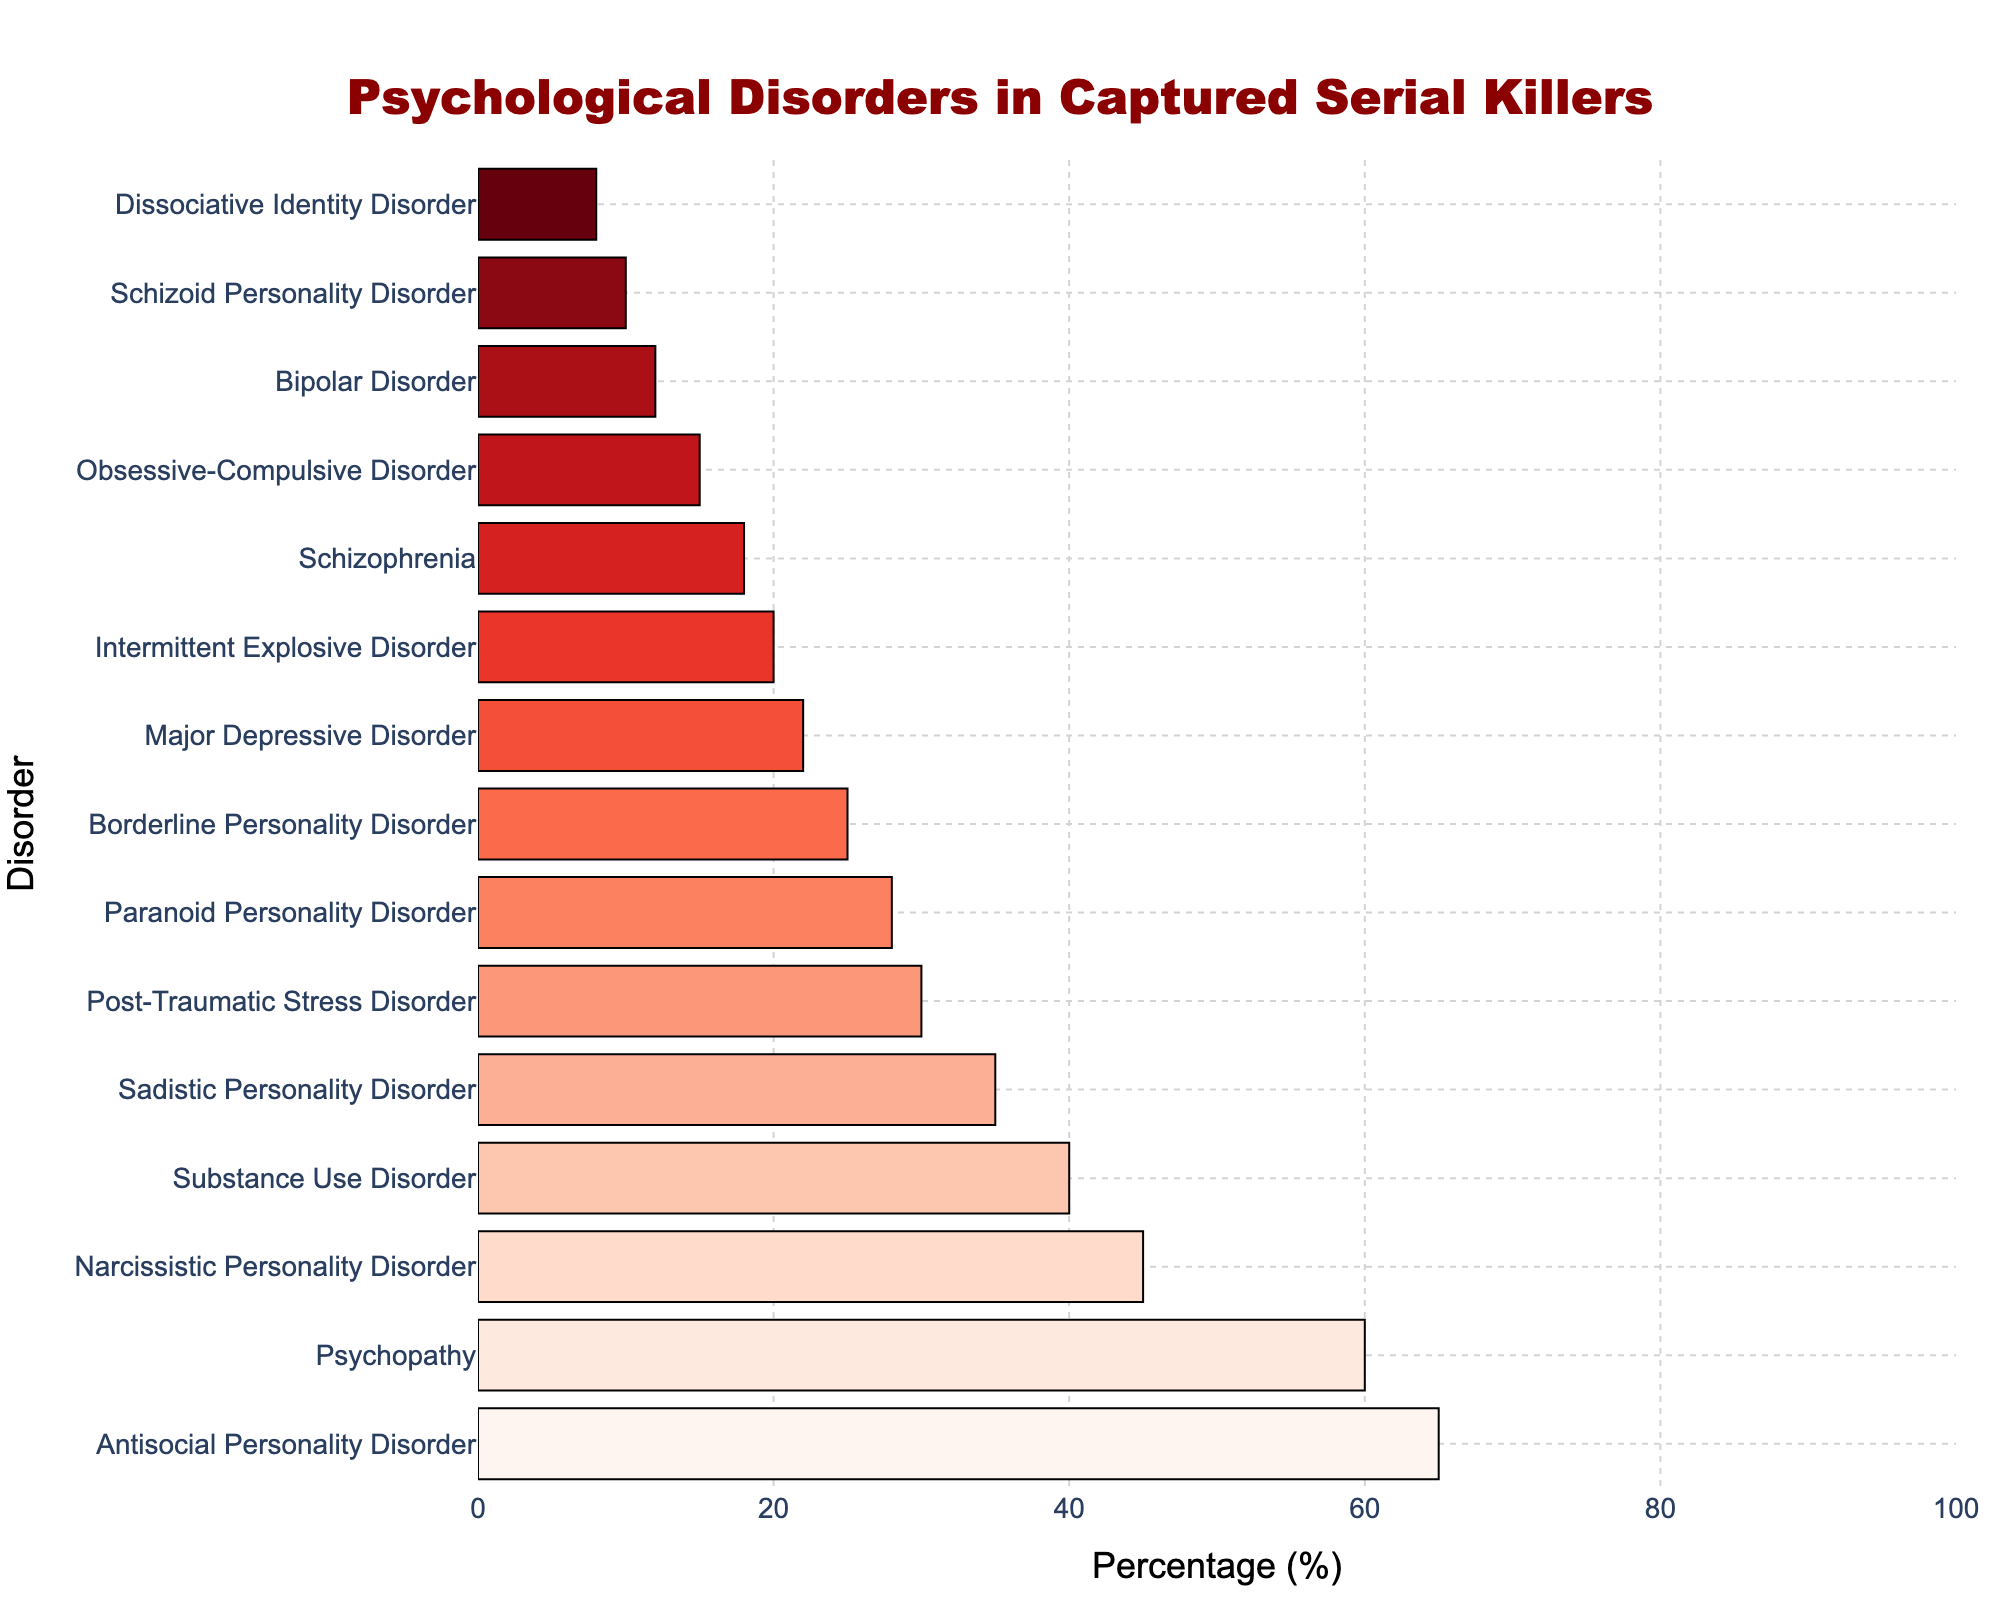Which disorder has the highest percentage among captured serial killers? The tallest bar represents the disorder with the highest percentage. Antisocial Personality Disorder has the tallest bar with a value of 65%.
Answer: Antisocial Personality Disorder Which disorder is diagnosed in 60% of captured serial killers? The bar with a length of 60% corresponds to Psychopathy as shown by the figure.
Answer: Psychopathy Of the disorders listed, which has the lowest percentage and what is it? The shortest bar represents the disorder with the lowest percentage. This is Dissociative Identity Disorder at 8%.
Answer: Dissociative Identity Disorder How much more common is Narcissistic Personality Disorder compared to Bipolar Disorder? The percentage for Narcissistic Personality Disorder is 45% and for Bipolar Disorder is 12%. The difference is 45% - 12% = 33%.
Answer: 33% What is the combined percentage of captured serial killers diagnosed with Major Depressive Disorder and Schizophrenia? Summing the percentages for Major Depressive Disorder and Schizophrenia (22% + 18%) gives 40%.
Answer: 40% Between Sadistic Personality Disorder and Substance Use Disorder, which is more common and by how much? The percentage for Sadistic Personality Disorder is 35% and for Substance Use Disorder is 40%. Substance Use Disorder is more common by 40% - 35% = 5%.
Answer: Substance Use Disorder by 5% Does Borderline Personality Disorder have a higher or lower percentage than Post-Traumatic Stress Disorder? Comparing the bar lengths, Borderline Personality Disorder has a percentage of 25% while Post-Traumatic Stress Disorder has 30%. Borderline Personality Disorder has a lower percentage.
Answer: Lower What is the ratio of the percentage of serial killers diagnosed with Antisocial Personality Disorder to those diagnosed with Schizophrenia? The percentage for Antisocial Personality Disorder is 65%, and for Schizophrenia is 18%. The ratio is 65 / 18 ≈ 3.61.
Answer: 3.61 How many disorders have a percentage greater than 30? By counting all bars longer than the 30% mark, we find four disorders: Antisocial Personality Disorder, Psychopathy, Narcissistic Personality Disorder, and Substance Use Disorder.
Answer: 4 What is the average percentage across all the disorders listed? Sum all percentages: 65 + 60 + 45 + 25 + 18 + 12 + 30 + 8 + 15 + 35 + 40 + 22 + 28 + 10 + 20 = 433, divided by the number of disorders (15) gives 433 / 15 ≈ 28.87%.
Answer: 28.87% 